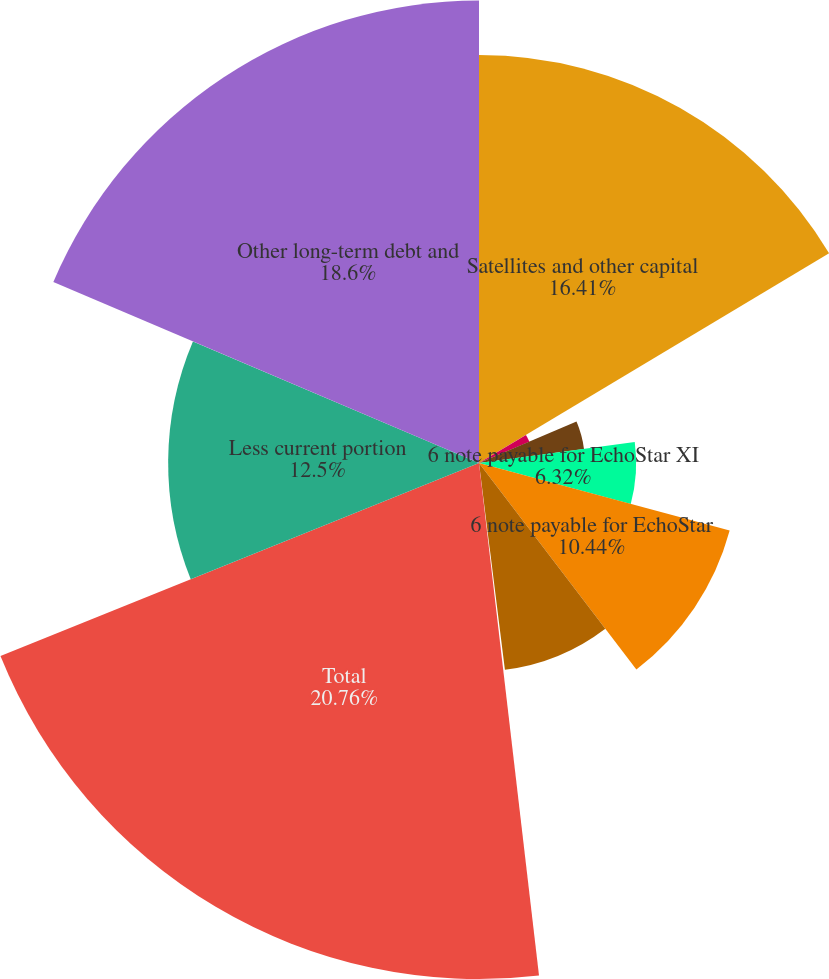Convert chart. <chart><loc_0><loc_0><loc_500><loc_500><pie_chart><fcel>Satellites and other capital<fcel>8 note payable for EchoStar<fcel>6 note payable for EchoStar X<fcel>6 note payable for EchoStar XI<fcel>6 note payable for EchoStar<fcel>6 note payable for EchoStar XV<fcel>Mortgages and other unsecured<fcel>Total<fcel>Less current portion<fcel>Other long-term debt and<nl><fcel>16.41%<fcel>2.2%<fcel>4.26%<fcel>6.32%<fcel>10.44%<fcel>8.38%<fcel>0.13%<fcel>20.75%<fcel>12.5%<fcel>18.6%<nl></chart> 